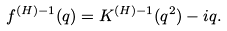Convert formula to latex. <formula><loc_0><loc_0><loc_500><loc_500>f ^ { ( H ) - 1 } ( q ) = K ^ { ( H ) - 1 } ( q ^ { 2 } ) - i q .</formula> 